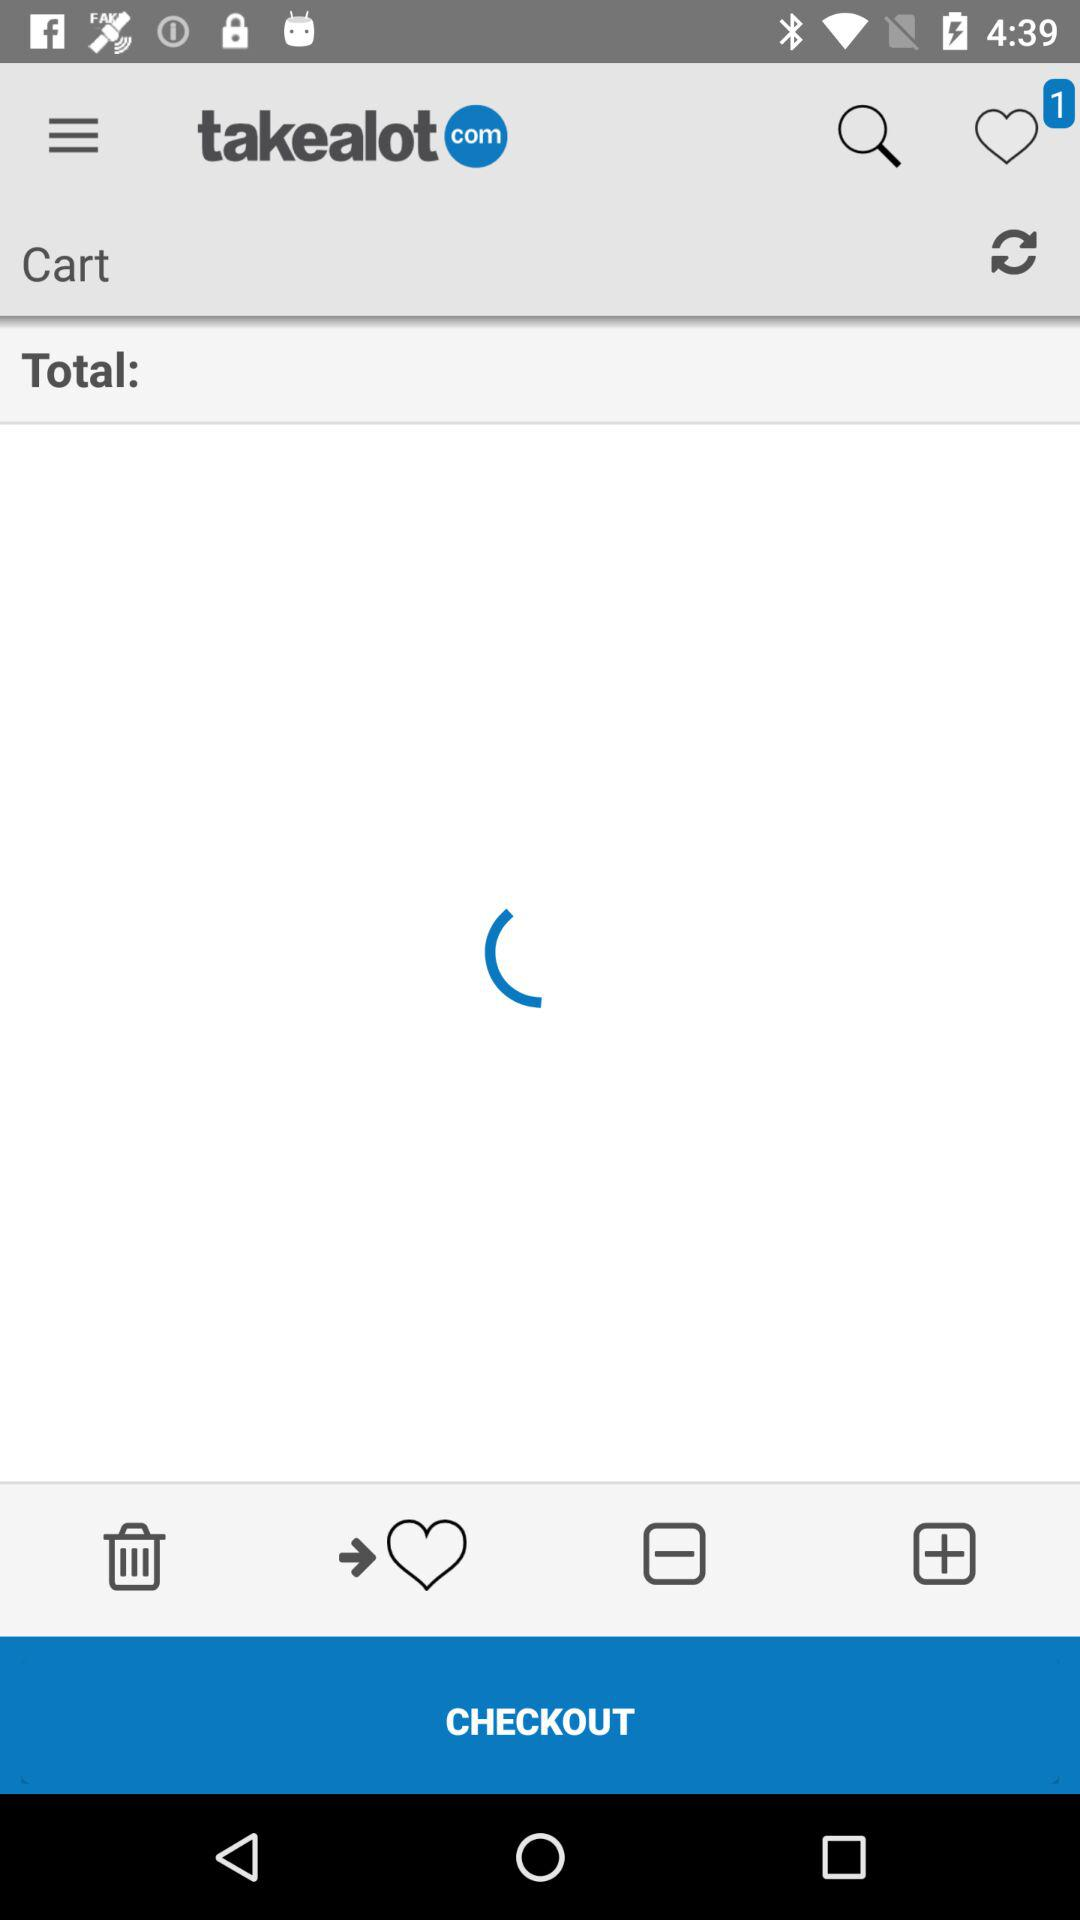What is the application name? The application name is "takealot". 